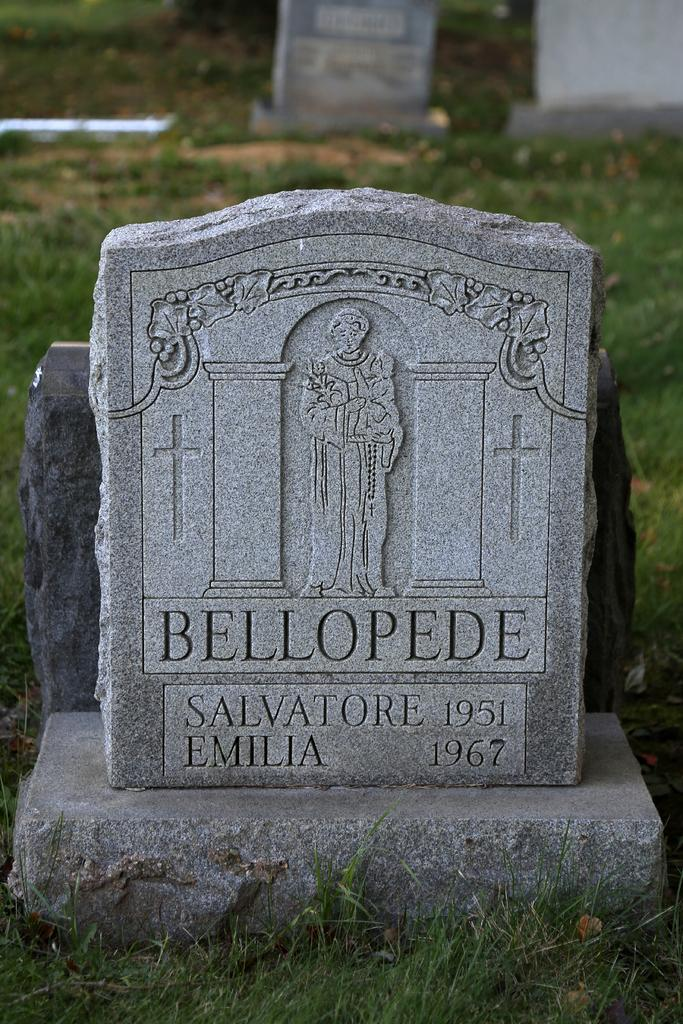What is the main subject of the image? The main subject of the image is a grave. What information is provided on the grave? The name of the person is mentioned on the grave. What type of vegetable is growing next to the grave in the image? There is no vegetable present or growing next to the grave in the image. What time of day is it in the image? The time of day is not mentioned or visible in the image. Are there any bananas visible in the image? There are no bananas present in the image. 